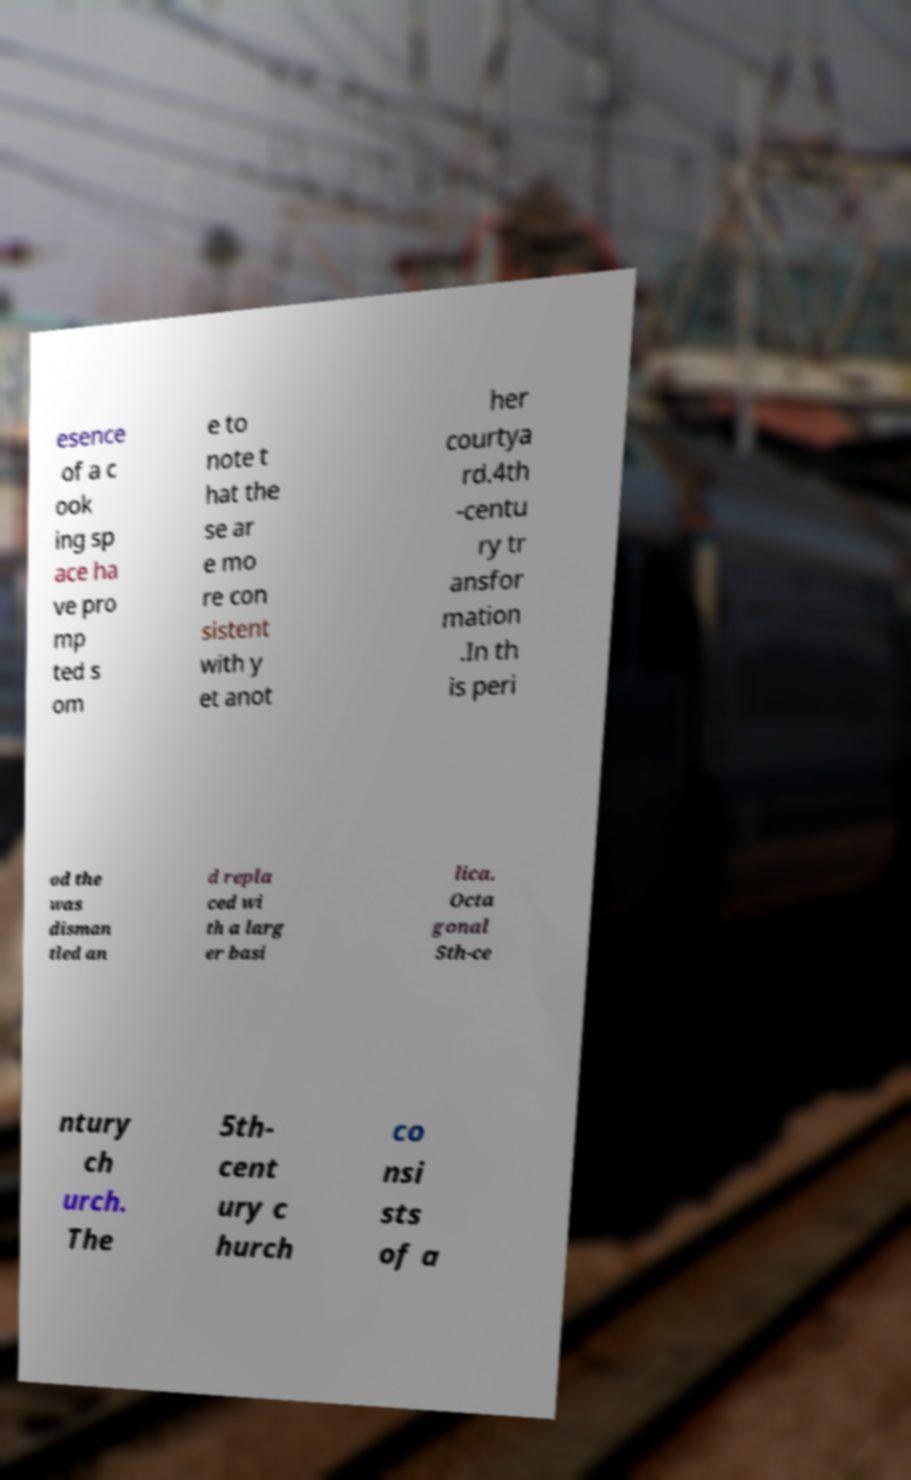Please read and relay the text visible in this image. What does it say? esence of a c ook ing sp ace ha ve pro mp ted s om e to note t hat the se ar e mo re con sistent with y et anot her courtya rd.4th -centu ry tr ansfor mation .In th is peri od the was disman tled an d repla ced wi th a larg er basi lica. Octa gonal 5th-ce ntury ch urch. The 5th- cent ury c hurch co nsi sts of a 